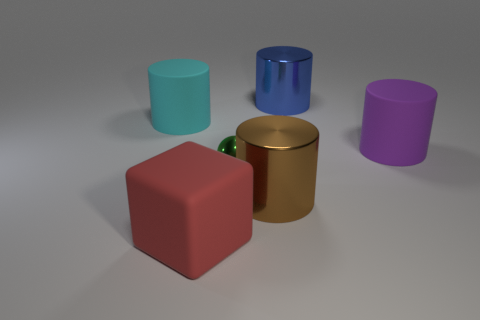How many red objects are small blocks or matte things?
Provide a succinct answer. 1. Are there any cylinders that have the same color as the small object?
Provide a succinct answer. No. What size is the purple cylinder that is the same material as the cyan object?
Give a very brief answer. Large. How many cylinders are either small blue shiny things or brown metallic things?
Your answer should be very brief. 1. Are there more yellow matte cubes than large purple things?
Provide a succinct answer. No. How many other objects are the same size as the brown shiny object?
Offer a very short reply. 4. How many things are rubber objects on the right side of the blue cylinder or large purple matte cylinders?
Give a very brief answer. 1. Is the number of blue shiny things less than the number of small yellow rubber blocks?
Offer a terse response. No. There is a red object that is made of the same material as the big cyan cylinder; what shape is it?
Give a very brief answer. Cube. There is a brown metallic thing; are there any large rubber things in front of it?
Your answer should be compact. Yes. 